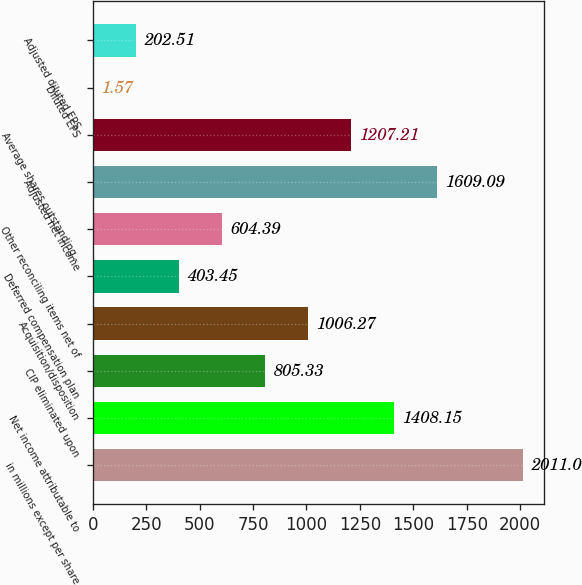Convert chart to OTSL. <chart><loc_0><loc_0><loc_500><loc_500><bar_chart><fcel>in millions except per share<fcel>Net income attributable to<fcel>CIP eliminated upon<fcel>Acquisition/disposition<fcel>Deferred compensation plan<fcel>Other reconciling items net of<fcel>Adjusted net income<fcel>Average shares outstanding -<fcel>Diluted EPS<fcel>Adjusted diluted EPS<nl><fcel>2011<fcel>1408.15<fcel>805.33<fcel>1006.27<fcel>403.45<fcel>604.39<fcel>1609.09<fcel>1207.21<fcel>1.57<fcel>202.51<nl></chart> 